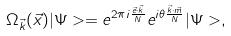<formula> <loc_0><loc_0><loc_500><loc_500>\Omega _ { \vec { k } } ( \vec { x } ) | \Psi > = e ^ { 2 \pi i \frac { \vec { e } \cdot \vec { k } } { N } } e ^ { i \theta \frac { \vec { k } \cdot \vec { m } } { N } } | \Psi > ,</formula> 